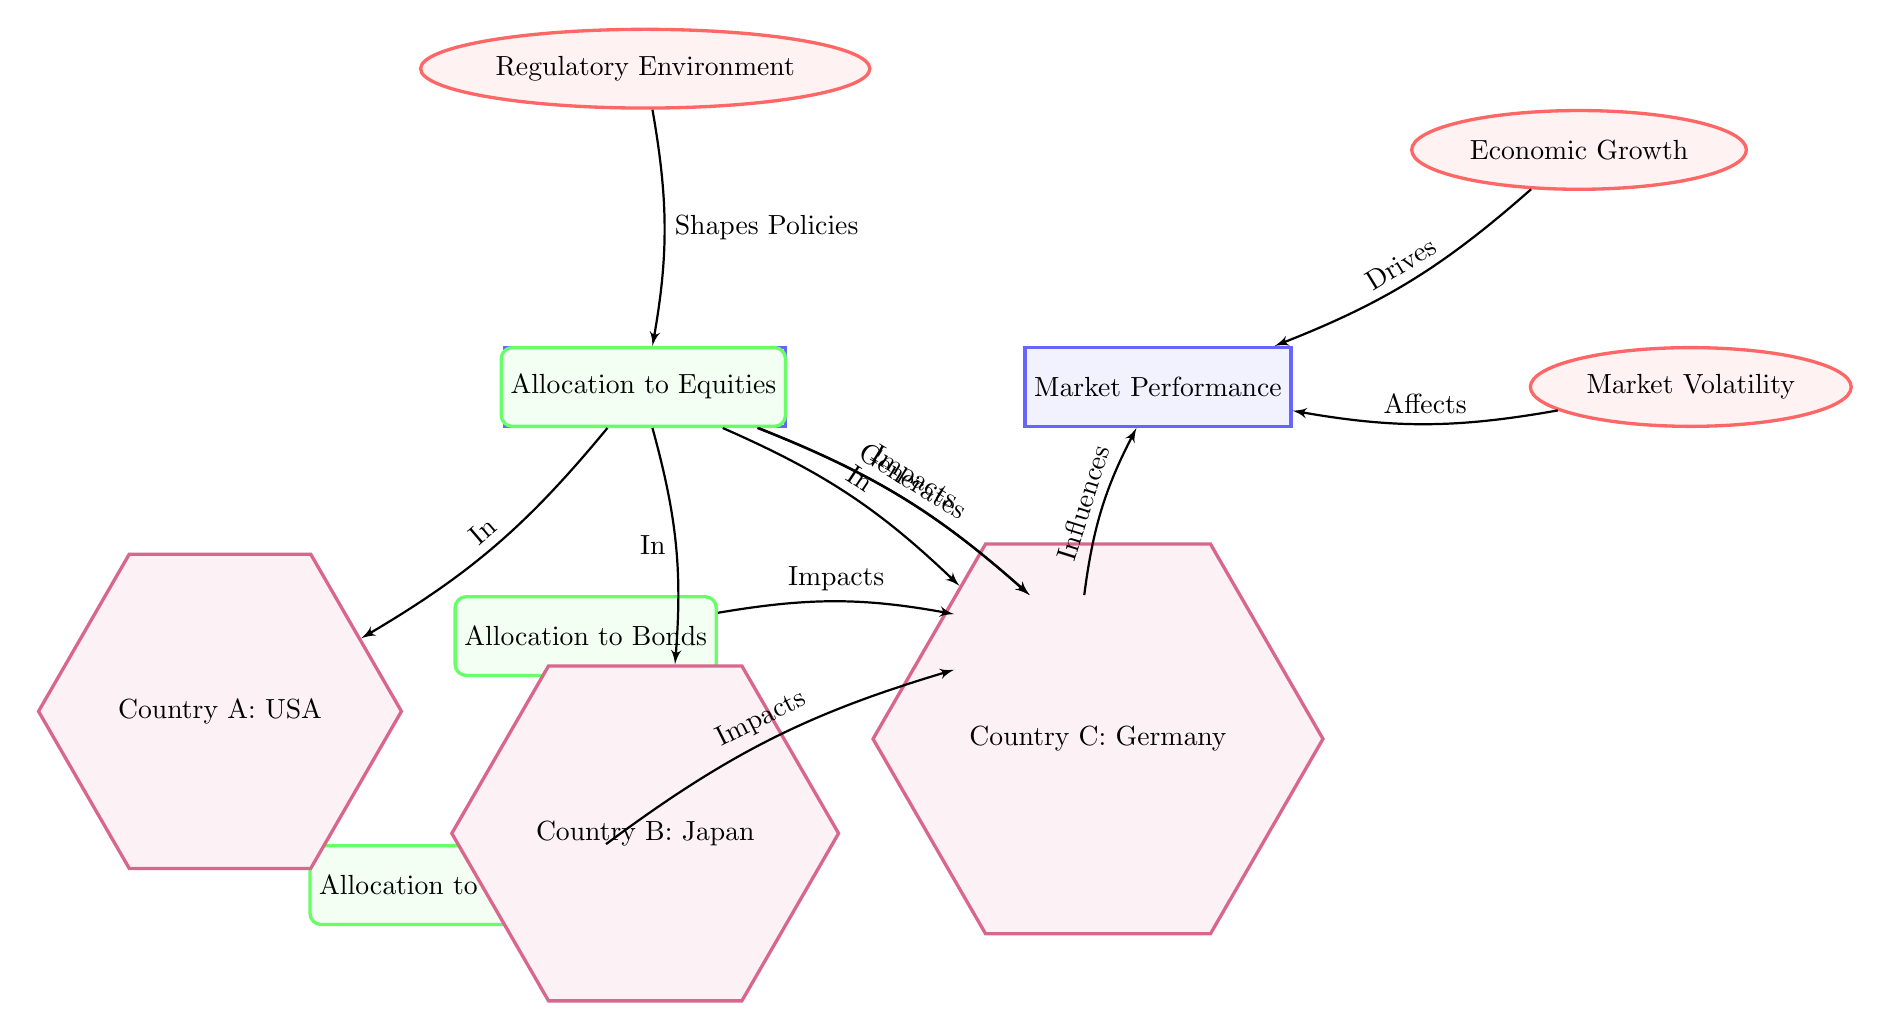What are the three types of allocations made by public pension funds? The diagram lists three types of allocations: Allocation to Equities, Allocation to Bonds, and Allocation to Alternative Investments. These are shown as activities branching from the Public Pension Funds node.
Answer: Allocation to Equities, Allocation to Bonds, Allocation to Alternative Investments What drives market performance according to the diagram? The diagram indicates that Economic Growth drives Market Performance, connecting these two entities with an edge labeled "Drives."
Answer: Economic Growth Which country is represented as Country A in the diagram? The diagram designates Country A as the USA, shown in the location node that branches from the Public Pension Funds node.
Answer: USA How many factors influence market performance? There are two factors listed in the diagram that influence Market Performance: Economic Growth and Market Volatility. Each is an ellipse shape connected to Market Performance with arrows labeled "Drives" and "Affects," respectively.
Answer: 2 What shapes the policies regarding public pension funds? The Regulatory Environment is indicated in the diagram as shaping the policies related to Public Pension Funds, with an edge connecting it to the Public Pension Funds node labeled "Shapes Policies."
Answer: Regulatory Environment Which type of investment allocation impacts investment return? All three types of investment allocations—Allocation to Equities, Allocation to Bonds, and Allocation to Alternative Investments—are shown to impact Investment Return as demonstrated by the directed edges from each allocation node to the Investment Return node.
Answer: All three If market volatility increases, how might it affect market performance? The diagram shows that Market Volatility affects Market Performance, suggesting an inverse or negative relationship where increased volatility could likely lead to decreased performance, as indicated by the edge labeled "Affects."
Answer: Decreased performance What is the relationship between public pension funds and investment return? The diagram illustrates a direct relationship where Public Pension Funds generate Investment Return. This is indicated by the arrow labeled "Generates" connecting the Public Pension Funds and Investment Return nodes.
Answer: Generates Which country has its public pension fund impacted by the regulatory environment? The diagram shows that the Regulatory Environment influences all three countries: USA, Japan, and Germany, as indicated by the directed edge leading from Regulatory Environment to the Public Pension Funds of these countries.
Answer: All three countries 